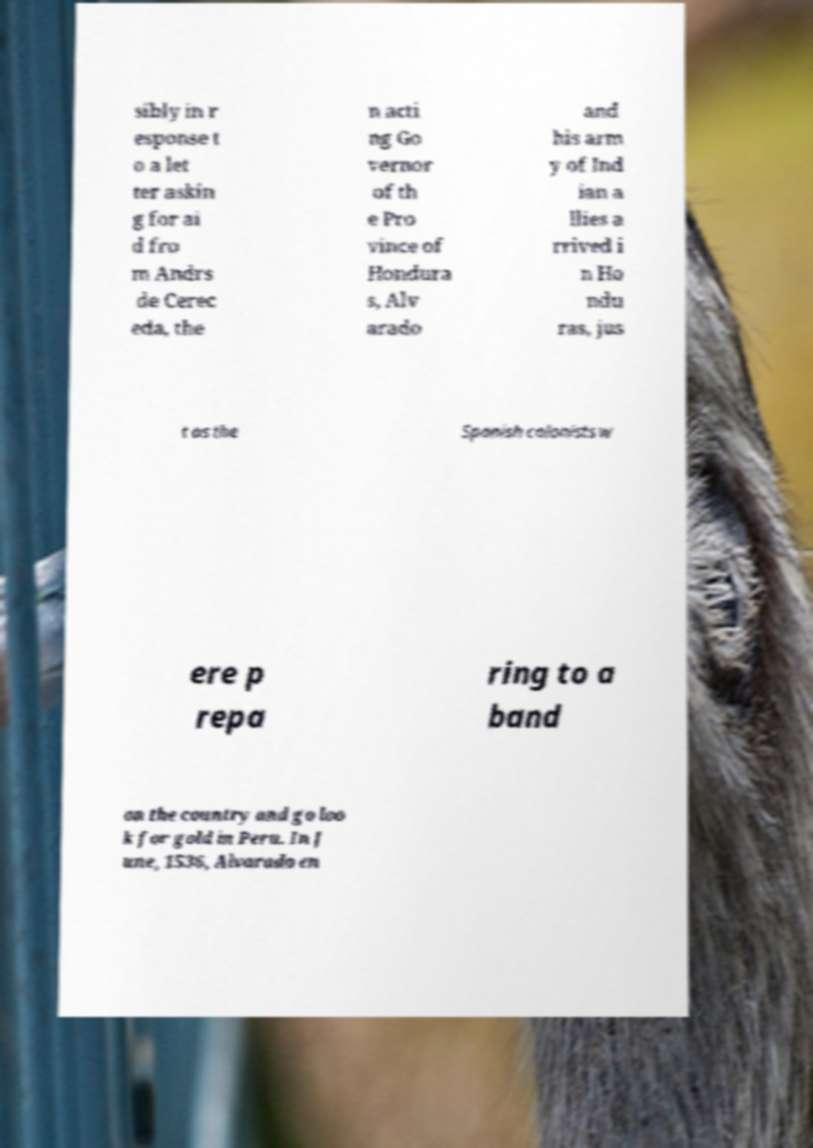Could you extract and type out the text from this image? sibly in r esponse t o a let ter askin g for ai d fro m Andrs de Cerec eda, the n acti ng Go vernor of th e Pro vince of Hondura s, Alv arado and his arm y of Ind ian a llies a rrived i n Ho ndu ras, jus t as the Spanish colonists w ere p repa ring to a band on the country and go loo k for gold in Peru. In J une, 1536, Alvarado en 